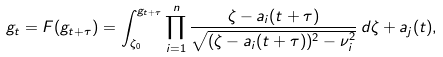Convert formula to latex. <formula><loc_0><loc_0><loc_500><loc_500>g _ { t } = F ( g _ { t + \tau } ) = \int _ { \zeta _ { 0 } } ^ { g _ { t + \tau } } \prod _ { i = 1 } ^ { n } \frac { \zeta - a _ { i } ( t + \tau ) } { \sqrt { ( \zeta - a _ { i } ( t + \tau ) ) ^ { 2 } - \nu _ { i } ^ { 2 } } } \, d \zeta + a _ { j } ( t ) ,</formula> 